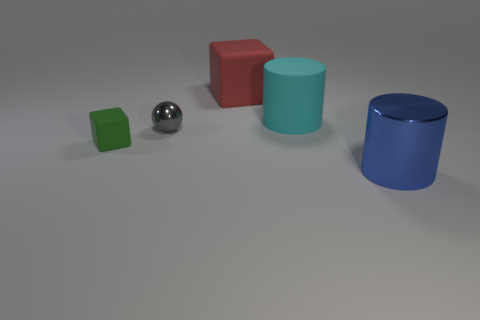Is the cube in front of the gray sphere made of the same material as the big cylinder in front of the gray object?
Provide a succinct answer. No. There is a tiny green matte thing that is left of the large cylinder in front of the large cylinder behind the large blue cylinder; what is its shape?
Give a very brief answer. Cube. What is the shape of the cyan thing?
Your answer should be compact. Cylinder. There is a cyan rubber thing that is the same size as the blue cylinder; what is its shape?
Your answer should be compact. Cylinder. There is a metal thing on the left side of the shiny cylinder; does it have the same shape as the big object in front of the big cyan cylinder?
Your response must be concise. No. How many things are either objects in front of the tiny gray metal object or big cylinders that are behind the small sphere?
Offer a terse response. 3. What number of other objects are there of the same material as the red cube?
Give a very brief answer. 2. Are the tiny thing to the left of the tiny ball and the red cube made of the same material?
Your response must be concise. Yes. Is the number of large objects that are in front of the red matte thing greater than the number of large cyan matte objects that are in front of the blue thing?
Provide a succinct answer. Yes. What number of things are either large cylinders in front of the green rubber cube or gray objects?
Offer a terse response. 2. 